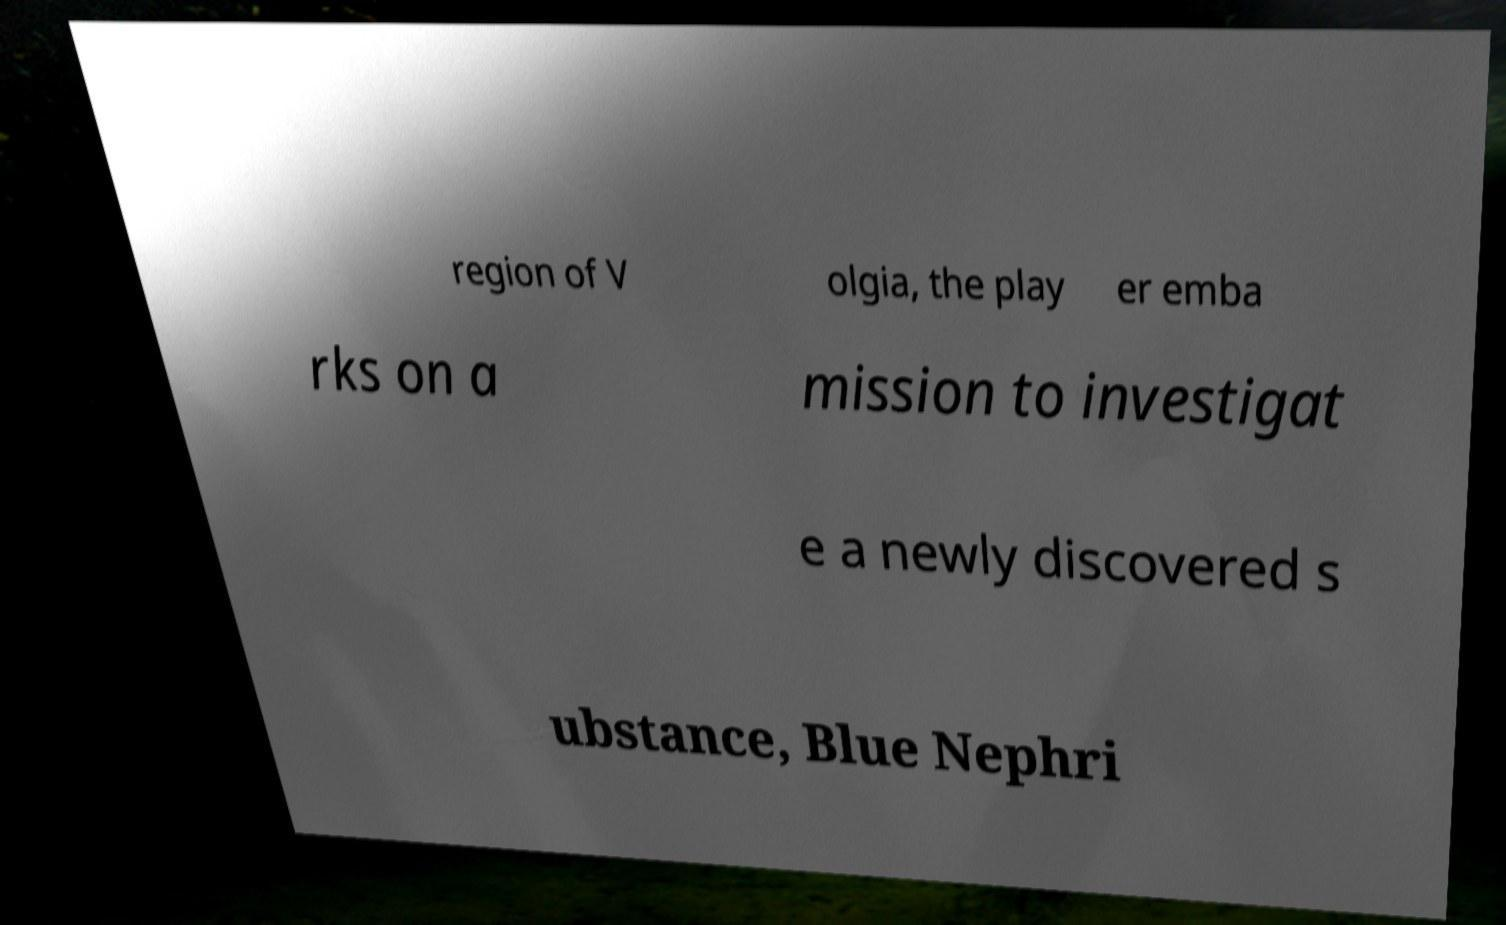For documentation purposes, I need the text within this image transcribed. Could you provide that? region of V olgia, the play er emba rks on a mission to investigat e a newly discovered s ubstance, Blue Nephri 